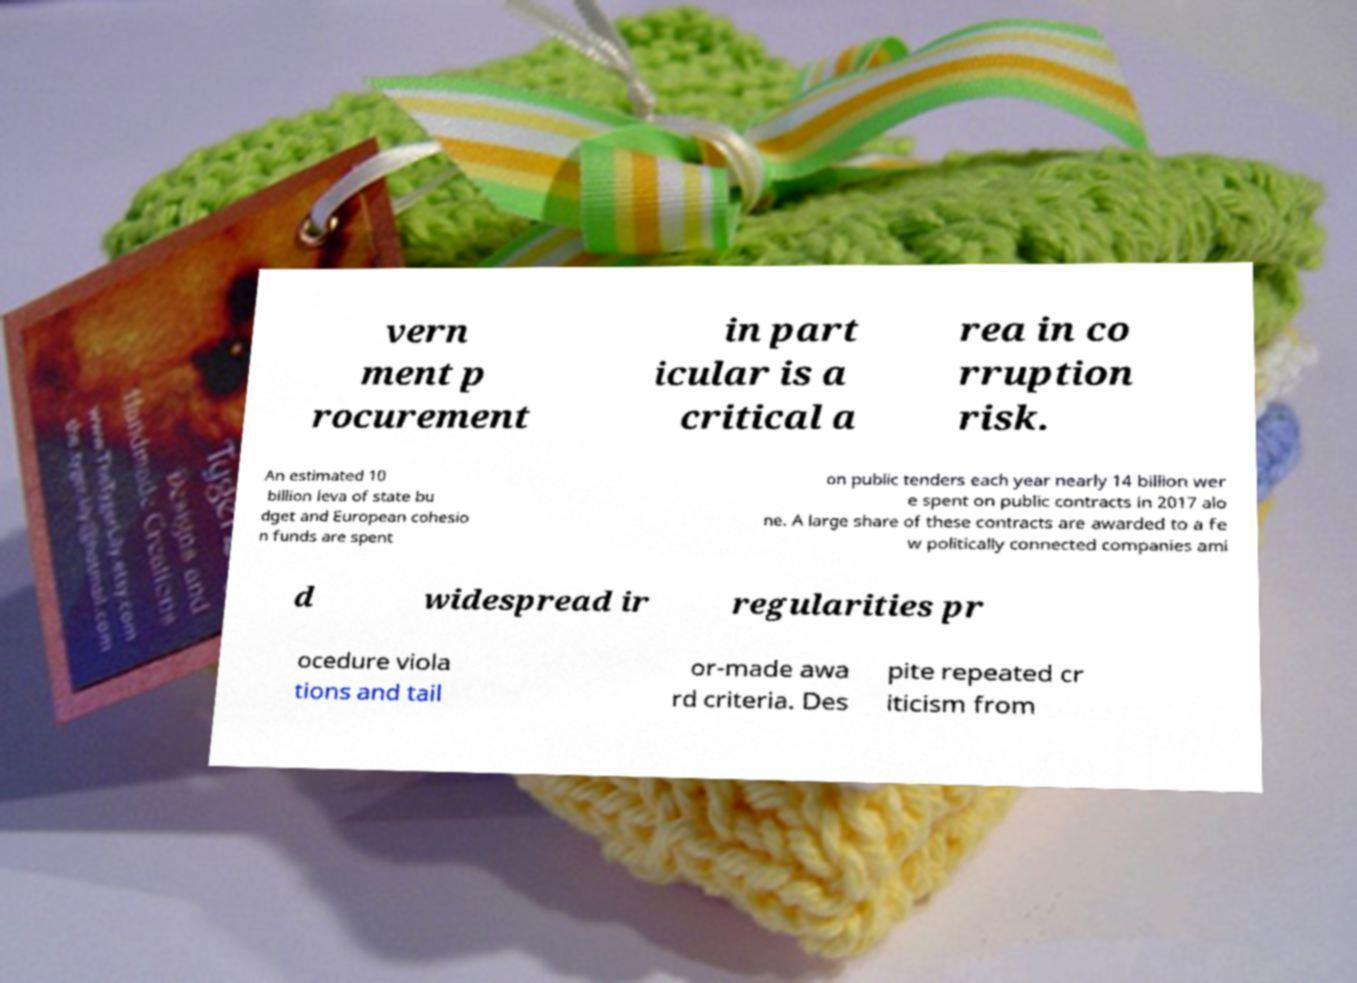Can you accurately transcribe the text from the provided image for me? vern ment p rocurement in part icular is a critical a rea in co rruption risk. An estimated 10 billion leva of state bu dget and European cohesio n funds are spent on public tenders each year nearly 14 billion wer e spent on public contracts in 2017 alo ne. A large share of these contracts are awarded to a fe w politically connected companies ami d widespread ir regularities pr ocedure viola tions and tail or-made awa rd criteria. Des pite repeated cr iticism from 